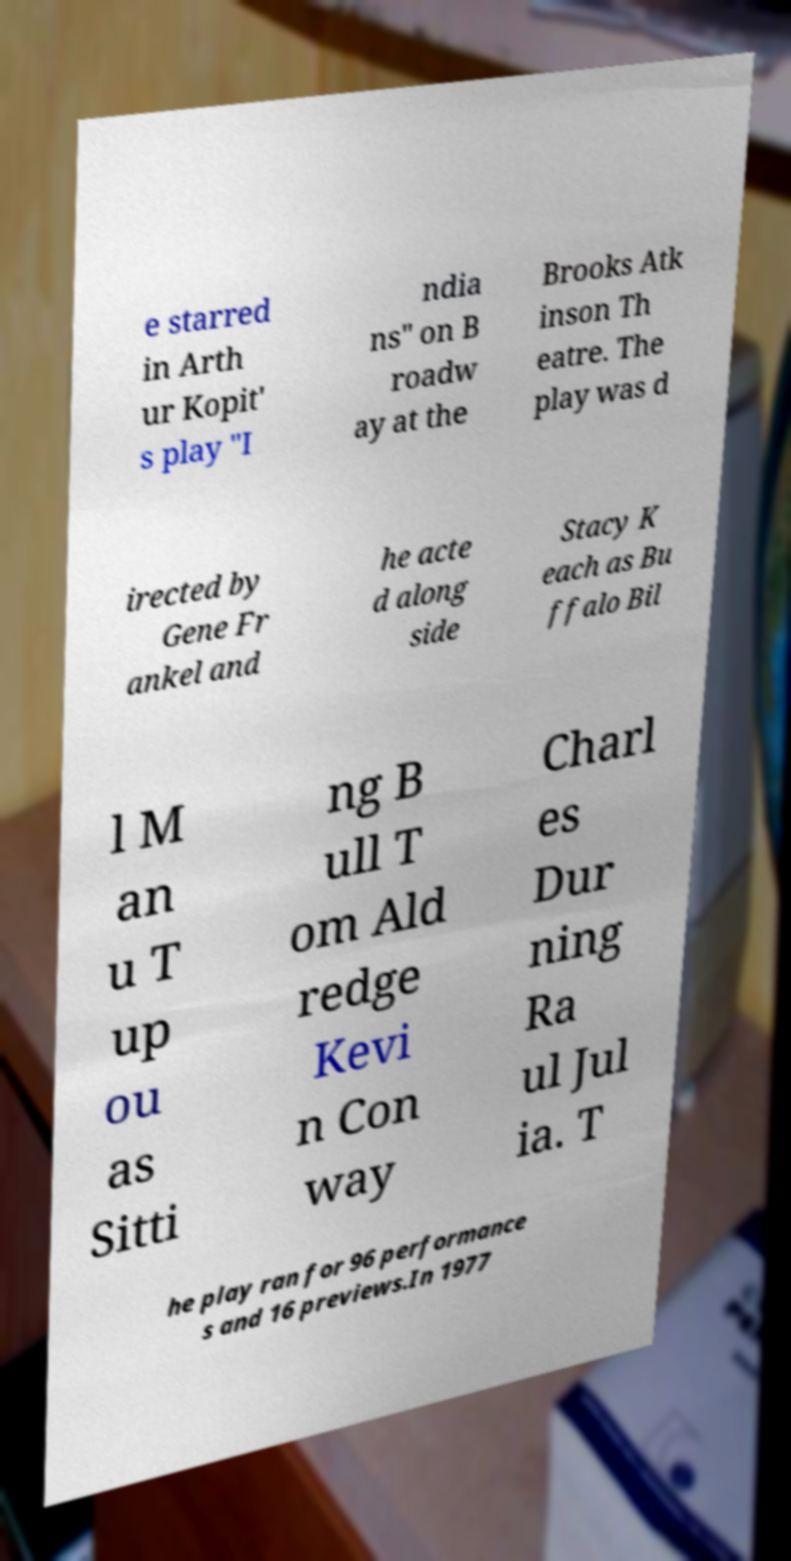What messages or text are displayed in this image? I need them in a readable, typed format. e starred in Arth ur Kopit' s play "I ndia ns" on B roadw ay at the Brooks Atk inson Th eatre. The play was d irected by Gene Fr ankel and he acte d along side Stacy K each as Bu ffalo Bil l M an u T up ou as Sitti ng B ull T om Ald redge Kevi n Con way Charl es Dur ning Ra ul Jul ia. T he play ran for 96 performance s and 16 previews.In 1977 